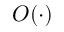<formula> <loc_0><loc_0><loc_500><loc_500>O ( \cdot )</formula> 